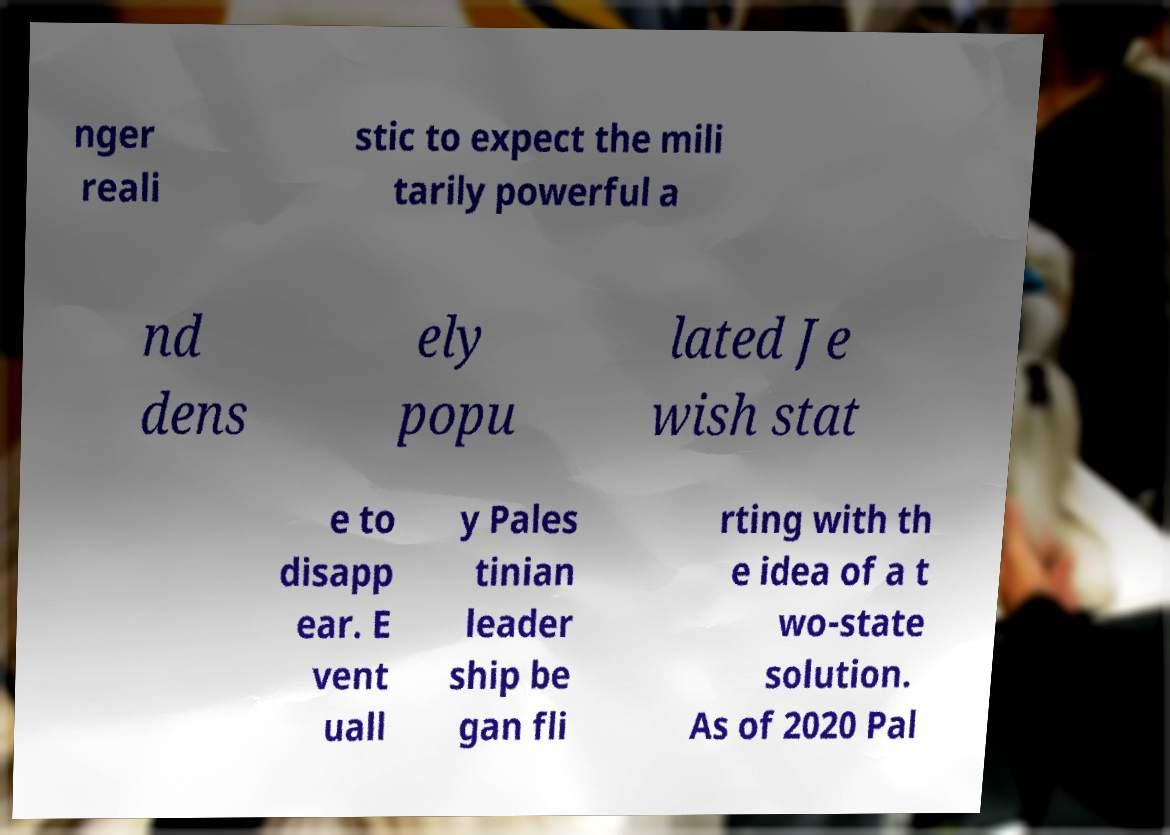Could you extract and type out the text from this image? nger reali stic to expect the mili tarily powerful a nd dens ely popu lated Je wish stat e to disapp ear. E vent uall y Pales tinian leader ship be gan fli rting with th e idea of a t wo-state solution. As of 2020 Pal 